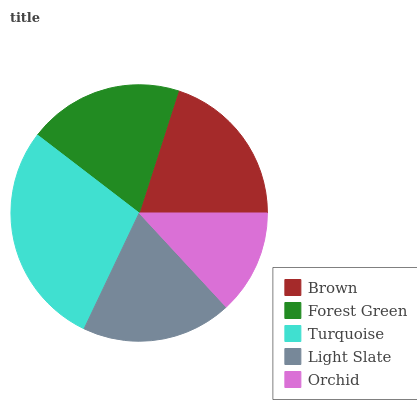Is Orchid the minimum?
Answer yes or no. Yes. Is Turquoise the maximum?
Answer yes or no. Yes. Is Forest Green the minimum?
Answer yes or no. No. Is Forest Green the maximum?
Answer yes or no. No. Is Brown greater than Forest Green?
Answer yes or no. Yes. Is Forest Green less than Brown?
Answer yes or no. Yes. Is Forest Green greater than Brown?
Answer yes or no. No. Is Brown less than Forest Green?
Answer yes or no. No. Is Forest Green the high median?
Answer yes or no. Yes. Is Forest Green the low median?
Answer yes or no. Yes. Is Light Slate the high median?
Answer yes or no. No. Is Light Slate the low median?
Answer yes or no. No. 